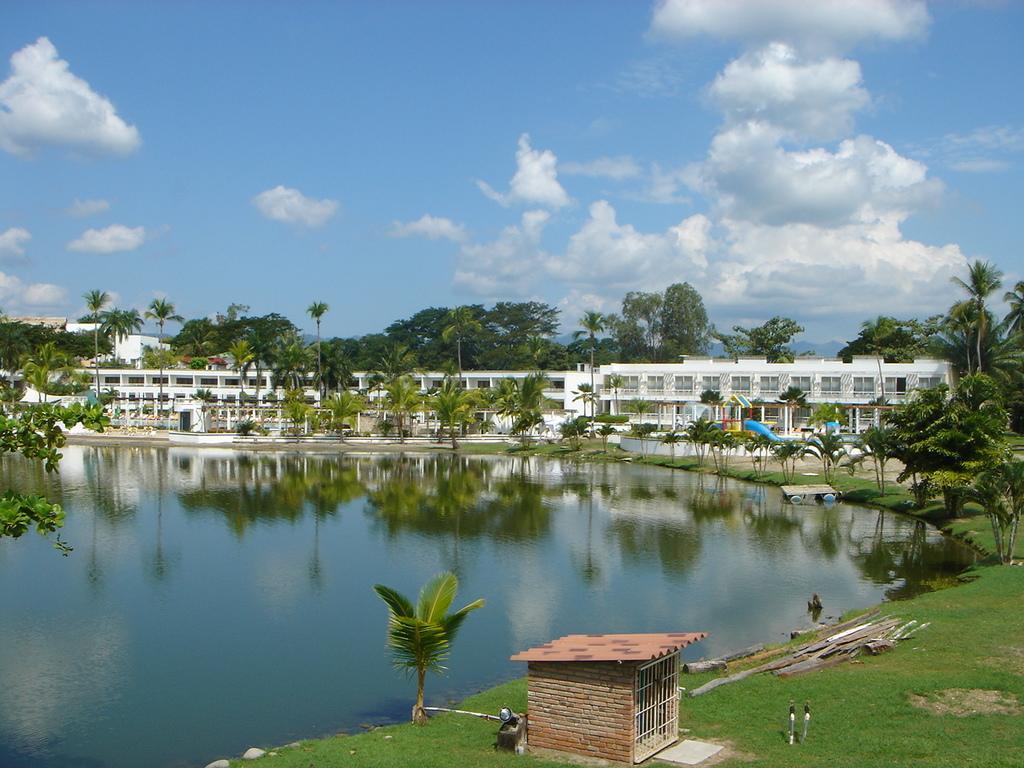Could you give a brief overview of what you see in this image? In the image there is grass, trees, water surface and buildings. 